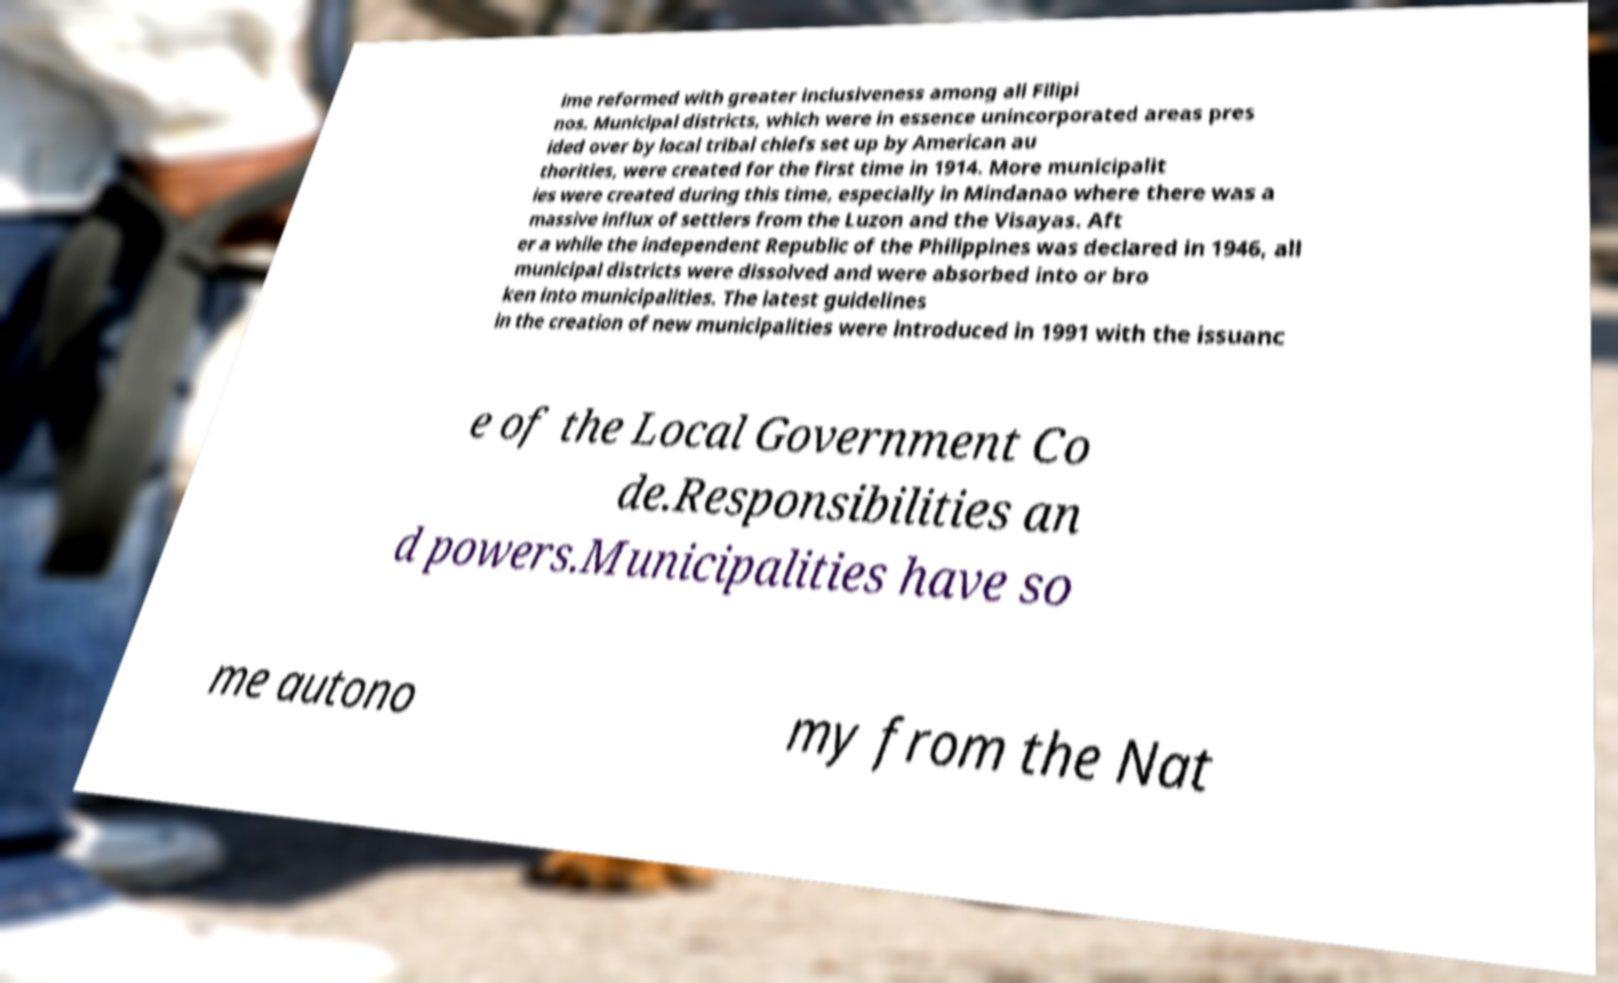What messages or text are displayed in this image? I need them in a readable, typed format. ime reformed with greater inclusiveness among all Filipi nos. Municipal districts, which were in essence unincorporated areas pres ided over by local tribal chiefs set up by American au thorities, were created for the first time in 1914. More municipalit ies were created during this time, especially in Mindanao where there was a massive influx of settlers from the Luzon and the Visayas. Aft er a while the independent Republic of the Philippines was declared in 1946, all municipal districts were dissolved and were absorbed into or bro ken into municipalities. The latest guidelines in the creation of new municipalities were introduced in 1991 with the issuanc e of the Local Government Co de.Responsibilities an d powers.Municipalities have so me autono my from the Nat 